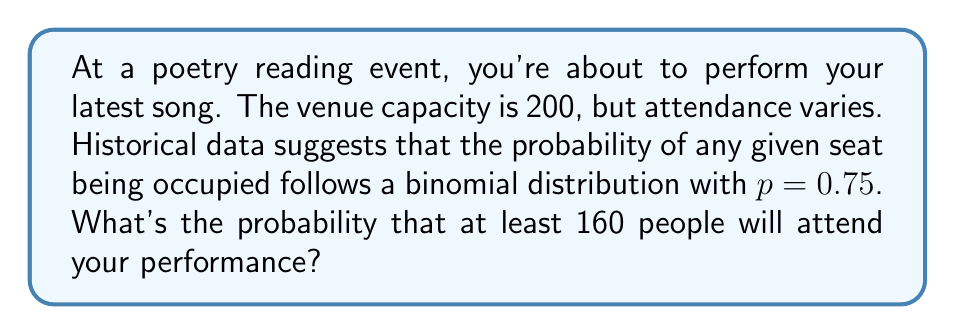Show me your answer to this math problem. To solve this problem, we'll use the binomial distribution and the concept of cumulative probability.

1) Let $X$ be the number of people attending. $X$ follows a binomial distribution with parameters $n = 200$ and $p = 0.75$.

2) We want to find $P(X \geq 160)$. This is equivalent to $1 - P(X < 160)$ or $1 - P(X \leq 159)$.

3) For large $n$, we can approximate the binomial distribution with a normal distribution:

   $X \sim N(\mu, \sigma^2)$, where:
   $\mu = np = 200 \cdot 0.75 = 150$
   $\sigma^2 = np(1-p) = 200 \cdot 0.75 \cdot 0.25 = 37.5$
   $\sigma = \sqrt{37.5} \approx 6.12$

4) We need to standardize our value:

   $z = \frac{159.5 - 150}{6.12} \approx 1.55$

   Note: We use 159.5 instead of 159 for continuity correction.

5) Now, we need to find $P(Z > 1.55)$ = $1 - P(Z \leq 1.55)$

6) Using a standard normal table or calculator:

   $P(Z \leq 1.55) \approx 0.9394$

7) Therefore, $P(X \geq 160) = 1 - 0.9394 = 0.0606$
Answer: 0.0606 